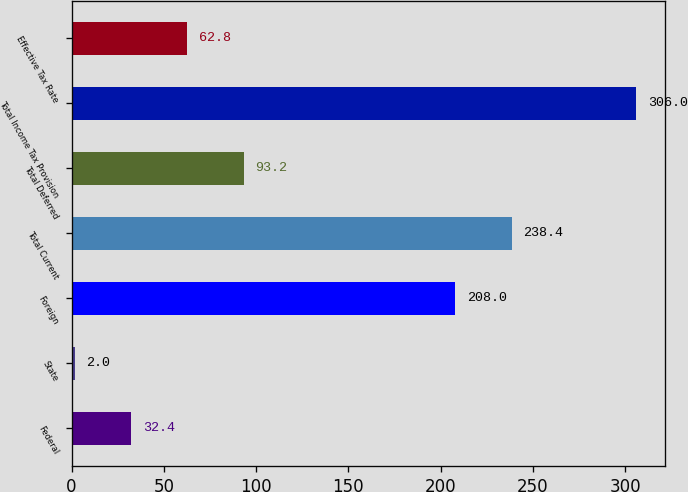Convert chart. <chart><loc_0><loc_0><loc_500><loc_500><bar_chart><fcel>Federal<fcel>State<fcel>Foreign<fcel>Total Current<fcel>Total Deferred<fcel>Total Income Tax Provision<fcel>Effective Tax Rate<nl><fcel>32.4<fcel>2<fcel>208<fcel>238.4<fcel>93.2<fcel>306<fcel>62.8<nl></chart> 